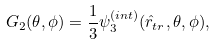Convert formula to latex. <formula><loc_0><loc_0><loc_500><loc_500>G _ { 2 } ( \theta , \phi ) = \frac { 1 } { 3 } \psi _ { 3 } ^ { ( i n t ) } ( \hat { r } _ { t r } , \theta , \phi ) ,</formula> 